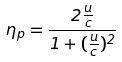<formula> <loc_0><loc_0><loc_500><loc_500>\eta _ { p } = \frac { 2 \frac { u } { c } } { 1 + ( \frac { u } { c } ) ^ { 2 } }</formula> 